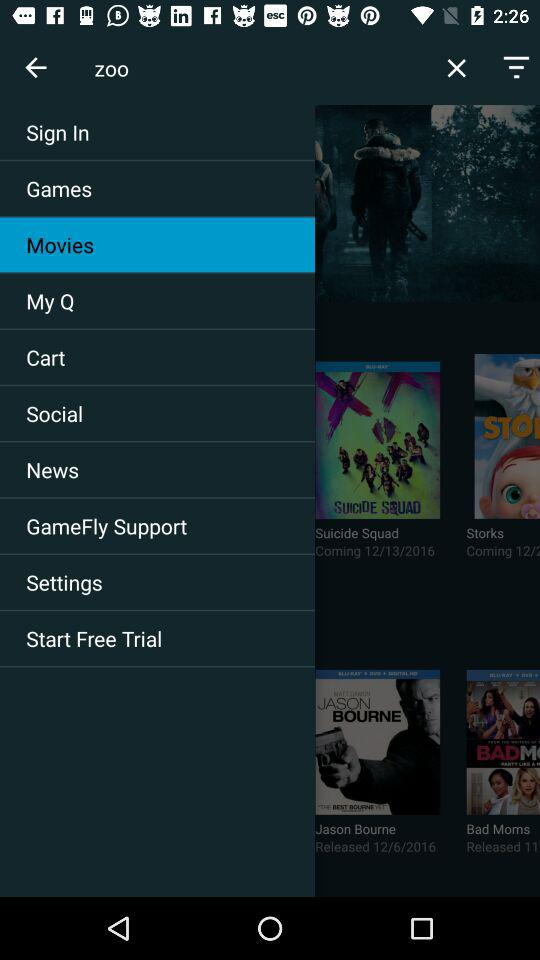Which item has been selected? The item "Movies" has been selected. 